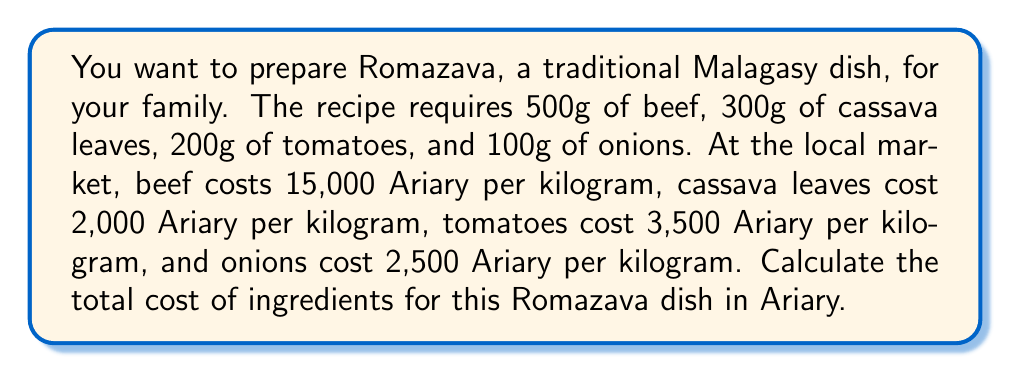Teach me how to tackle this problem. Let's calculate the cost of each ingredient separately and then sum them up:

1. Beef:
   - Price: 15,000 Ariary/kg = 15 Ariary/g
   - Quantity: 500g
   - Cost: $500 \times 15 = 7,500$ Ariary

2. Cassava leaves:
   - Price: 2,000 Ariary/kg = 2 Ariary/g
   - Quantity: 300g
   - Cost: $300 \times 2 = 600$ Ariary

3. Tomatoes:
   - Price: 3,500 Ariary/kg = 3.5 Ariary/g
   - Quantity: 200g
   - Cost: $200 \times 3.5 = 700$ Ariary

4. Onions:
   - Price: 2,500 Ariary/kg = 2.5 Ariary/g
   - Quantity: 100g
   - Cost: $100 \times 2.5 = 250$ Ariary

Now, we sum up the costs of all ingredients:

$$\text{Total cost} = 7,500 + 600 + 700 + 250 = 9,050 \text{ Ariary}$$
Answer: 9,050 Ariary 